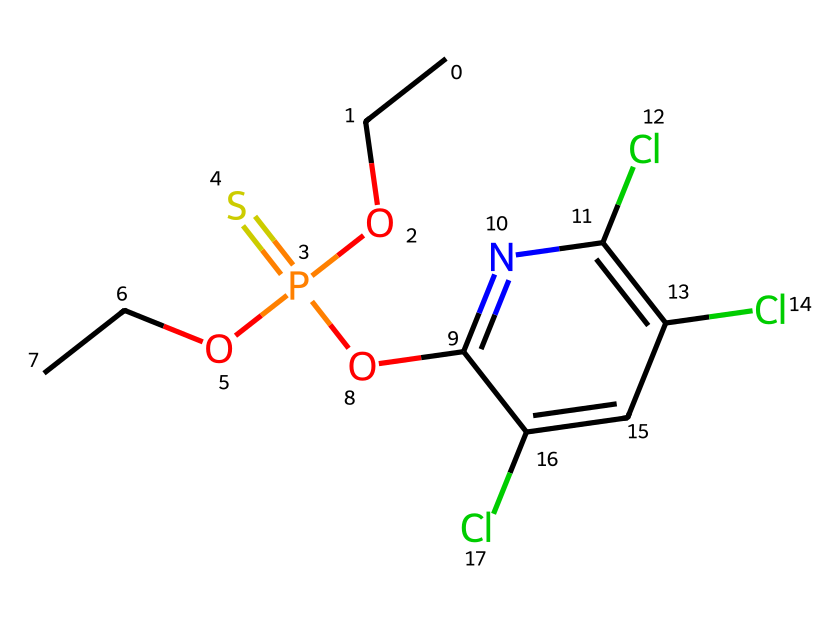What is the molecular formula of chlorpyrifos? By examining the SMILES representation, we can count the different types of atoms. The chemical consists of 12 carbon (C) atoms, 14 hydrogen (H) atoms, 4 chlorine (Cl) atoms, 1 nitrogen (N) atom, 1 phosphorus (P) atom, and 1 oxygen (O) atom. Thus, the total molecular formula is C12H14Cl4N O3PS.
Answer: C12H14Cl4N O3PS How many chlorine atoms are present in chlorpyrifos? Looking at the SMILES structure, we can identify three 'Cl' symbols. Counting these gives us a total of three chlorine atoms in the compound.
Answer: 3 What type of bond connects the phosphorus to the nitrogen in chlorpyrifos? Analyzing the structure, we can see there are single bonds connecting phosphorus (P) with both oxygen and nitrogen. The specific bond to nitrogen is a single covalent bond, which is characterized by the sharing of one pair of electrons between the two atoms.
Answer: single covalent bond Which functional group is present in chlorpyrifos that indicates it is a pesticide? The compound contains a phosphate group (P=O and P-O bonds), which is a characteristic functional group found in many insecticides, including chlorpyrifos. This structure is responsible for the compound's pesticidal activity.
Answer: phosphate group Is chlorpyrifos a systemic or contact pesticide? Chlorpyrifos is a systemic pesticide, meaning it is absorbed by plants and moves through their tissues, providing protection against pests that feed on them. This characteristic is due to its molecular structure, allowing for transport within plant tissues.
Answer: systemic 